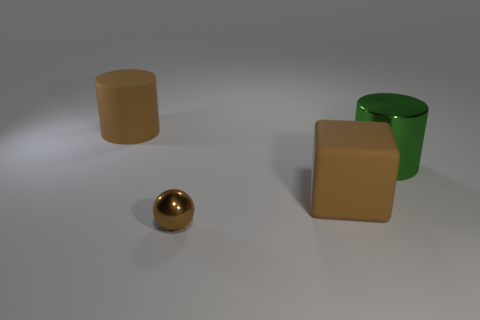How many other objects are the same color as the big matte block?
Your response must be concise. 2. Does the small metal thing have the same shape as the green object?
Your answer should be compact. No. Is there a big green cylinder made of the same material as the sphere?
Make the answer very short. Yes. Is there a metal thing that is on the right side of the big matte object that is in front of the big green metal cylinder?
Make the answer very short. Yes. There is a cylinder that is to the right of the brown cube; is its size the same as the matte cylinder?
Your answer should be very brief. Yes. The shiny cylinder is what size?
Provide a short and direct response. Large. Are there any matte blocks that have the same color as the ball?
Your response must be concise. Yes. How many big things are cyan rubber balls or brown metallic objects?
Offer a terse response. 0. There is a object that is on the left side of the matte cube and behind the cube; what size is it?
Provide a succinct answer. Large. There is a green thing; how many brown cubes are to the left of it?
Offer a very short reply. 1. 